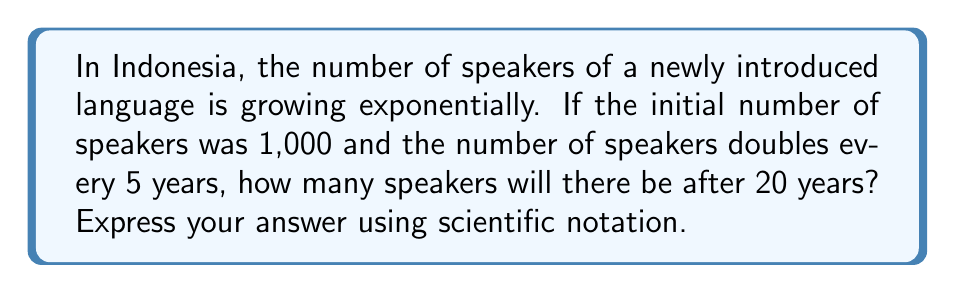Give your solution to this math problem. Let's approach this step-by-step:

1) We start with the basic exponential growth formula:
   $A = P(1 + r)^t$
   Where:
   $A$ = final amount
   $P$ = initial amount
   $r$ = growth rate
   $t$ = time

2) In this case:
   $P = 1,000$ (initial speakers)
   The population doubles every 5 years, so in 1 year, the growth rate is:
   $(1 + r)^5 = 2$
   $1 + r = 2^{\frac{1}{5}}$
   $r = 2^{\frac{1}{5}} - 1 \approx 0.1487$ or about 14.87% per year

3) The time period is 20 years, so $t = 20$

4) Now we can plug these values into our formula:
   $A = 1,000(1 + 0.1487)^{20}$

5) Let's calculate this:
   $A = 1,000(1.1487)^{20}$
   $A = 1,000(16.4456)$
   $A = 16,445.6$

6) Rounding to the nearest whole number:
   $A = 16,446$

7) In scientific notation, this is:
   $A = 1.6446 \times 10^4$
Answer: $1.6446 \times 10^4$ 